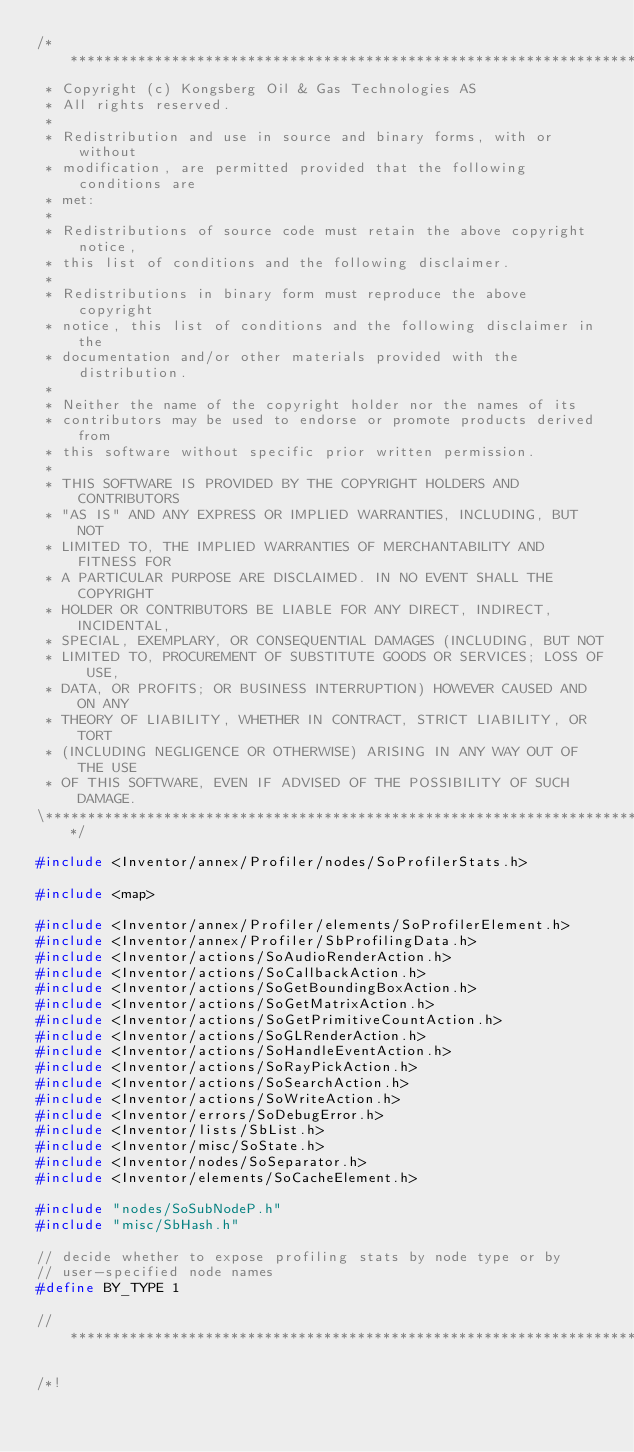<code> <loc_0><loc_0><loc_500><loc_500><_C++_>/**************************************************************************\
 * Copyright (c) Kongsberg Oil & Gas Technologies AS
 * All rights reserved.
 * 
 * Redistribution and use in source and binary forms, with or without
 * modification, are permitted provided that the following conditions are
 * met:
 * 
 * Redistributions of source code must retain the above copyright notice,
 * this list of conditions and the following disclaimer.
 * 
 * Redistributions in binary form must reproduce the above copyright
 * notice, this list of conditions and the following disclaimer in the
 * documentation and/or other materials provided with the distribution.
 * 
 * Neither the name of the copyright holder nor the names of its
 * contributors may be used to endorse or promote products derived from
 * this software without specific prior written permission.
 * 
 * THIS SOFTWARE IS PROVIDED BY THE COPYRIGHT HOLDERS AND CONTRIBUTORS
 * "AS IS" AND ANY EXPRESS OR IMPLIED WARRANTIES, INCLUDING, BUT NOT
 * LIMITED TO, THE IMPLIED WARRANTIES OF MERCHANTABILITY AND FITNESS FOR
 * A PARTICULAR PURPOSE ARE DISCLAIMED. IN NO EVENT SHALL THE COPYRIGHT
 * HOLDER OR CONTRIBUTORS BE LIABLE FOR ANY DIRECT, INDIRECT, INCIDENTAL,
 * SPECIAL, EXEMPLARY, OR CONSEQUENTIAL DAMAGES (INCLUDING, BUT NOT
 * LIMITED TO, PROCUREMENT OF SUBSTITUTE GOODS OR SERVICES; LOSS OF USE,
 * DATA, OR PROFITS; OR BUSINESS INTERRUPTION) HOWEVER CAUSED AND ON ANY
 * THEORY OF LIABILITY, WHETHER IN CONTRACT, STRICT LIABILITY, OR TORT
 * (INCLUDING NEGLIGENCE OR OTHERWISE) ARISING IN ANY WAY OUT OF THE USE
 * OF THIS SOFTWARE, EVEN IF ADVISED OF THE POSSIBILITY OF SUCH DAMAGE.
\**************************************************************************/

#include <Inventor/annex/Profiler/nodes/SoProfilerStats.h>

#include <map>

#include <Inventor/annex/Profiler/elements/SoProfilerElement.h>
#include <Inventor/annex/Profiler/SbProfilingData.h>
#include <Inventor/actions/SoAudioRenderAction.h>
#include <Inventor/actions/SoCallbackAction.h>
#include <Inventor/actions/SoGetBoundingBoxAction.h>
#include <Inventor/actions/SoGetMatrixAction.h>
#include <Inventor/actions/SoGetPrimitiveCountAction.h>
#include <Inventor/actions/SoGLRenderAction.h>
#include <Inventor/actions/SoHandleEventAction.h>
#include <Inventor/actions/SoRayPickAction.h>
#include <Inventor/actions/SoSearchAction.h>
#include <Inventor/actions/SoWriteAction.h>
#include <Inventor/errors/SoDebugError.h>
#include <Inventor/lists/SbList.h>
#include <Inventor/misc/SoState.h>
#include <Inventor/nodes/SoSeparator.h>
#include <Inventor/elements/SoCacheElement.h>

#include "nodes/SoSubNodeP.h"
#include "misc/SbHash.h"

// decide whether to expose profiling stats by node type or by
// user-specified node names
#define BY_TYPE 1

// *************************************************************************

/*!</code> 